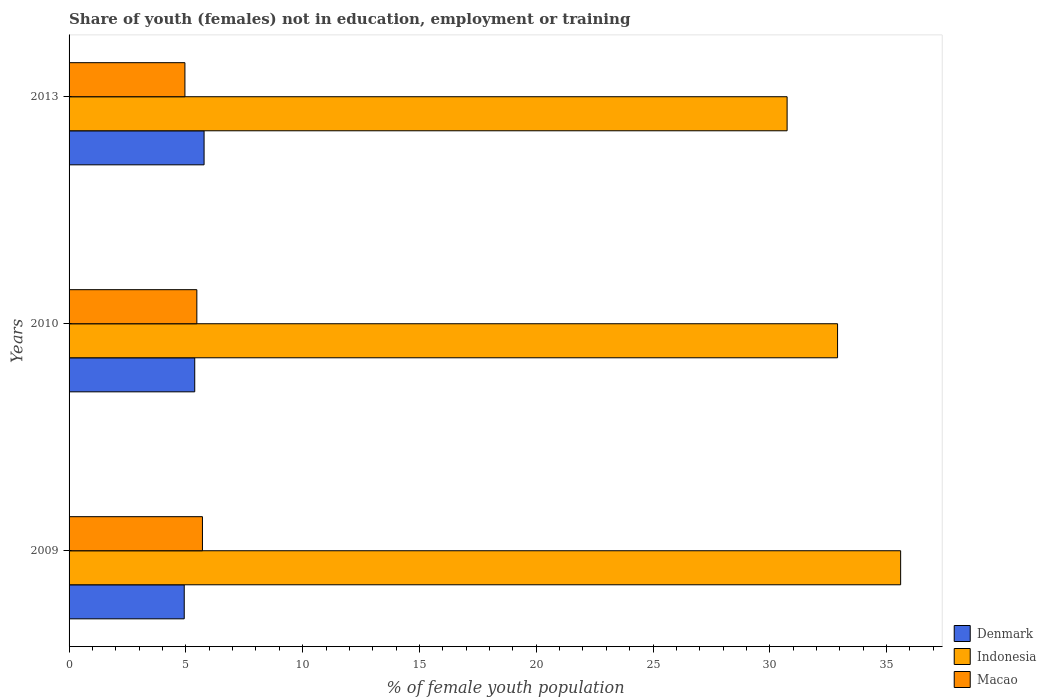How many different coloured bars are there?
Make the answer very short. 3. How many groups of bars are there?
Your answer should be very brief. 3. What is the label of the 3rd group of bars from the top?
Offer a very short reply. 2009. In how many cases, is the number of bars for a given year not equal to the number of legend labels?
Your answer should be compact. 0. What is the percentage of unemployed female population in in Indonesia in 2010?
Make the answer very short. 32.9. Across all years, what is the maximum percentage of unemployed female population in in Denmark?
Make the answer very short. 5.78. Across all years, what is the minimum percentage of unemployed female population in in Denmark?
Offer a terse response. 4.93. In which year was the percentage of unemployed female population in in Denmark minimum?
Keep it short and to the point. 2009. What is the total percentage of unemployed female population in in Macao in the graph?
Keep it short and to the point. 16.14. What is the difference between the percentage of unemployed female population in in Denmark in 2010 and that in 2013?
Ensure brevity in your answer.  -0.4. What is the difference between the percentage of unemployed female population in in Indonesia in 2010 and the percentage of unemployed female population in in Denmark in 2009?
Your answer should be compact. 27.97. What is the average percentage of unemployed female population in in Denmark per year?
Offer a very short reply. 5.36. In the year 2010, what is the difference between the percentage of unemployed female population in in Denmark and percentage of unemployed female population in in Macao?
Your answer should be very brief. -0.09. What is the ratio of the percentage of unemployed female population in in Denmark in 2009 to that in 2010?
Your answer should be very brief. 0.92. What is the difference between the highest and the second highest percentage of unemployed female population in in Macao?
Your response must be concise. 0.24. What is the difference between the highest and the lowest percentage of unemployed female population in in Indonesia?
Keep it short and to the point. 4.86. Is the sum of the percentage of unemployed female population in in Indonesia in 2009 and 2010 greater than the maximum percentage of unemployed female population in in Denmark across all years?
Your answer should be very brief. Yes. What does the 3rd bar from the top in 2013 represents?
Offer a very short reply. Denmark. What does the 2nd bar from the bottom in 2009 represents?
Your answer should be very brief. Indonesia. Is it the case that in every year, the sum of the percentage of unemployed female population in in Indonesia and percentage of unemployed female population in in Macao is greater than the percentage of unemployed female population in in Denmark?
Keep it short and to the point. Yes. How many bars are there?
Provide a short and direct response. 9. Are all the bars in the graph horizontal?
Ensure brevity in your answer.  Yes. What is the difference between two consecutive major ticks on the X-axis?
Offer a terse response. 5. Are the values on the major ticks of X-axis written in scientific E-notation?
Your answer should be compact. No. Does the graph contain any zero values?
Give a very brief answer. No. Does the graph contain grids?
Your answer should be compact. No. Where does the legend appear in the graph?
Offer a terse response. Bottom right. How are the legend labels stacked?
Provide a succinct answer. Vertical. What is the title of the graph?
Ensure brevity in your answer.  Share of youth (females) not in education, employment or training. What is the label or title of the X-axis?
Provide a succinct answer. % of female youth population. What is the % of female youth population of Denmark in 2009?
Your answer should be very brief. 4.93. What is the % of female youth population of Indonesia in 2009?
Make the answer very short. 35.6. What is the % of female youth population in Macao in 2009?
Provide a succinct answer. 5.71. What is the % of female youth population of Denmark in 2010?
Your answer should be compact. 5.38. What is the % of female youth population in Indonesia in 2010?
Provide a short and direct response. 32.9. What is the % of female youth population of Macao in 2010?
Provide a short and direct response. 5.47. What is the % of female youth population in Denmark in 2013?
Provide a short and direct response. 5.78. What is the % of female youth population in Indonesia in 2013?
Provide a succinct answer. 30.74. What is the % of female youth population in Macao in 2013?
Give a very brief answer. 4.96. Across all years, what is the maximum % of female youth population of Denmark?
Your response must be concise. 5.78. Across all years, what is the maximum % of female youth population in Indonesia?
Ensure brevity in your answer.  35.6. Across all years, what is the maximum % of female youth population of Macao?
Give a very brief answer. 5.71. Across all years, what is the minimum % of female youth population in Denmark?
Your response must be concise. 4.93. Across all years, what is the minimum % of female youth population in Indonesia?
Ensure brevity in your answer.  30.74. Across all years, what is the minimum % of female youth population in Macao?
Ensure brevity in your answer.  4.96. What is the total % of female youth population of Denmark in the graph?
Provide a short and direct response. 16.09. What is the total % of female youth population of Indonesia in the graph?
Keep it short and to the point. 99.24. What is the total % of female youth population in Macao in the graph?
Ensure brevity in your answer.  16.14. What is the difference between the % of female youth population of Denmark in 2009 and that in 2010?
Give a very brief answer. -0.45. What is the difference between the % of female youth population of Macao in 2009 and that in 2010?
Provide a succinct answer. 0.24. What is the difference between the % of female youth population of Denmark in 2009 and that in 2013?
Your answer should be compact. -0.85. What is the difference between the % of female youth population of Indonesia in 2009 and that in 2013?
Your answer should be compact. 4.86. What is the difference between the % of female youth population in Indonesia in 2010 and that in 2013?
Your answer should be very brief. 2.16. What is the difference between the % of female youth population of Macao in 2010 and that in 2013?
Provide a short and direct response. 0.51. What is the difference between the % of female youth population of Denmark in 2009 and the % of female youth population of Indonesia in 2010?
Offer a terse response. -27.97. What is the difference between the % of female youth population in Denmark in 2009 and the % of female youth population in Macao in 2010?
Make the answer very short. -0.54. What is the difference between the % of female youth population of Indonesia in 2009 and the % of female youth population of Macao in 2010?
Offer a terse response. 30.13. What is the difference between the % of female youth population in Denmark in 2009 and the % of female youth population in Indonesia in 2013?
Provide a succinct answer. -25.81. What is the difference between the % of female youth population of Denmark in 2009 and the % of female youth population of Macao in 2013?
Provide a short and direct response. -0.03. What is the difference between the % of female youth population of Indonesia in 2009 and the % of female youth population of Macao in 2013?
Provide a succinct answer. 30.64. What is the difference between the % of female youth population in Denmark in 2010 and the % of female youth population in Indonesia in 2013?
Offer a very short reply. -25.36. What is the difference between the % of female youth population of Denmark in 2010 and the % of female youth population of Macao in 2013?
Your response must be concise. 0.42. What is the difference between the % of female youth population in Indonesia in 2010 and the % of female youth population in Macao in 2013?
Provide a short and direct response. 27.94. What is the average % of female youth population of Denmark per year?
Provide a short and direct response. 5.36. What is the average % of female youth population in Indonesia per year?
Your answer should be compact. 33.08. What is the average % of female youth population of Macao per year?
Your answer should be very brief. 5.38. In the year 2009, what is the difference between the % of female youth population of Denmark and % of female youth population of Indonesia?
Keep it short and to the point. -30.67. In the year 2009, what is the difference between the % of female youth population of Denmark and % of female youth population of Macao?
Provide a short and direct response. -0.78. In the year 2009, what is the difference between the % of female youth population in Indonesia and % of female youth population in Macao?
Ensure brevity in your answer.  29.89. In the year 2010, what is the difference between the % of female youth population of Denmark and % of female youth population of Indonesia?
Your answer should be compact. -27.52. In the year 2010, what is the difference between the % of female youth population in Denmark and % of female youth population in Macao?
Ensure brevity in your answer.  -0.09. In the year 2010, what is the difference between the % of female youth population in Indonesia and % of female youth population in Macao?
Your response must be concise. 27.43. In the year 2013, what is the difference between the % of female youth population in Denmark and % of female youth population in Indonesia?
Offer a very short reply. -24.96. In the year 2013, what is the difference between the % of female youth population of Denmark and % of female youth population of Macao?
Your answer should be very brief. 0.82. In the year 2013, what is the difference between the % of female youth population in Indonesia and % of female youth population in Macao?
Provide a succinct answer. 25.78. What is the ratio of the % of female youth population of Denmark in 2009 to that in 2010?
Provide a succinct answer. 0.92. What is the ratio of the % of female youth population in Indonesia in 2009 to that in 2010?
Give a very brief answer. 1.08. What is the ratio of the % of female youth population of Macao in 2009 to that in 2010?
Your answer should be compact. 1.04. What is the ratio of the % of female youth population in Denmark in 2009 to that in 2013?
Your response must be concise. 0.85. What is the ratio of the % of female youth population of Indonesia in 2009 to that in 2013?
Give a very brief answer. 1.16. What is the ratio of the % of female youth population in Macao in 2009 to that in 2013?
Provide a short and direct response. 1.15. What is the ratio of the % of female youth population in Denmark in 2010 to that in 2013?
Offer a very short reply. 0.93. What is the ratio of the % of female youth population in Indonesia in 2010 to that in 2013?
Offer a very short reply. 1.07. What is the ratio of the % of female youth population in Macao in 2010 to that in 2013?
Provide a succinct answer. 1.1. What is the difference between the highest and the second highest % of female youth population of Denmark?
Offer a terse response. 0.4. What is the difference between the highest and the second highest % of female youth population in Indonesia?
Offer a terse response. 2.7. What is the difference between the highest and the second highest % of female youth population of Macao?
Offer a terse response. 0.24. What is the difference between the highest and the lowest % of female youth population of Indonesia?
Your answer should be very brief. 4.86. What is the difference between the highest and the lowest % of female youth population in Macao?
Keep it short and to the point. 0.75. 